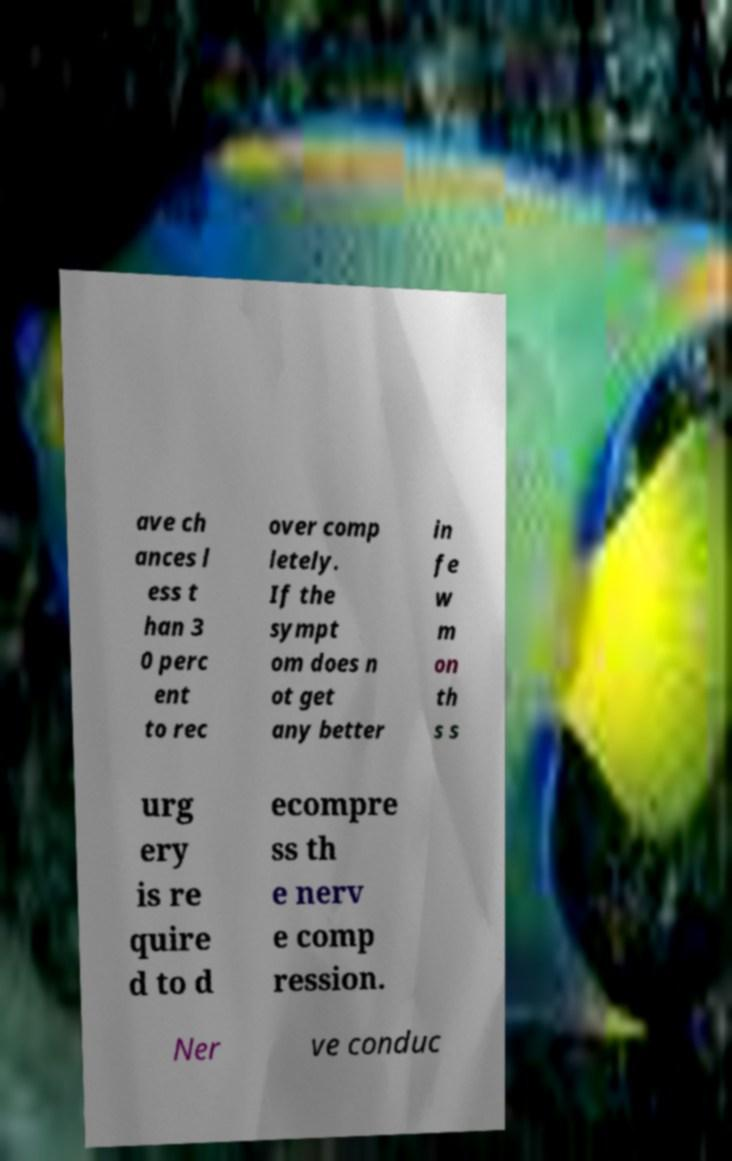Could you assist in decoding the text presented in this image and type it out clearly? ave ch ances l ess t han 3 0 perc ent to rec over comp letely. If the sympt om does n ot get any better in fe w m on th s s urg ery is re quire d to d ecompre ss th e nerv e comp ression. Ner ve conduc 